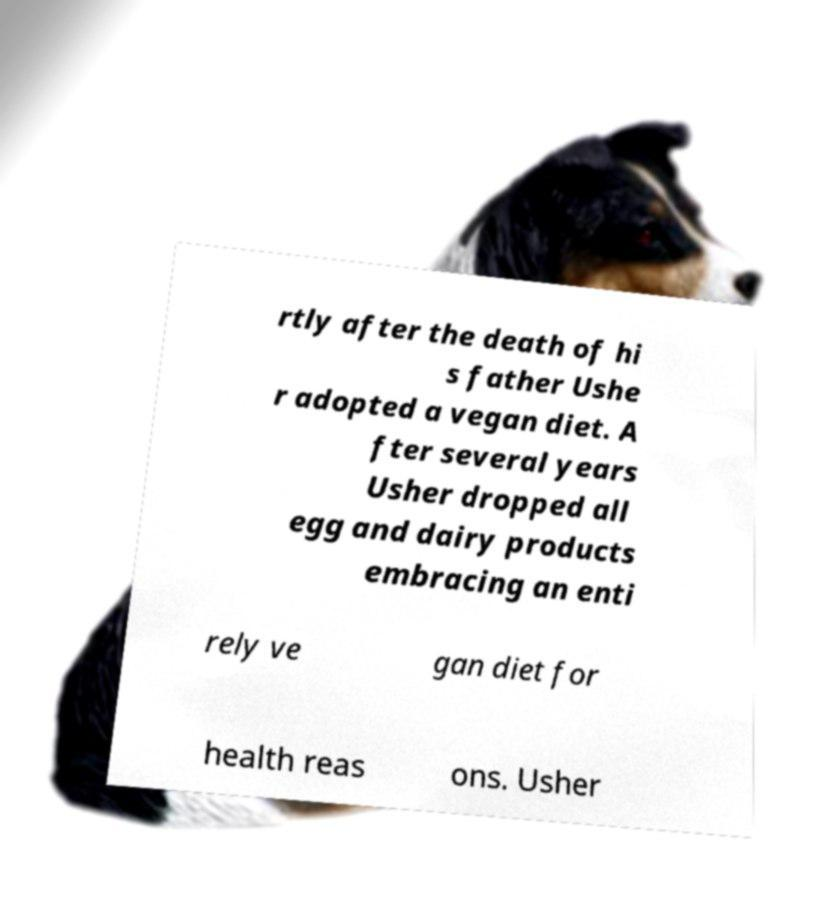What messages or text are displayed in this image? I need them in a readable, typed format. rtly after the death of hi s father Ushe r adopted a vegan diet. A fter several years Usher dropped all egg and dairy products embracing an enti rely ve gan diet for health reas ons. Usher 